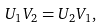Convert formula to latex. <formula><loc_0><loc_0><loc_500><loc_500>U _ { 1 } V _ { 2 } = U _ { 2 } V _ { 1 } ,</formula> 